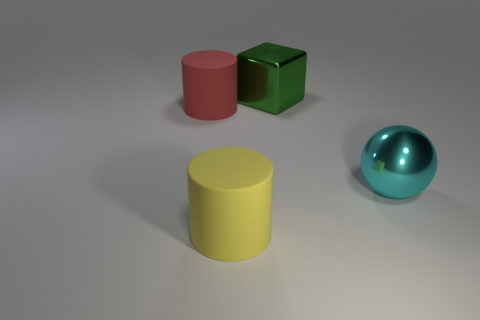What number of other objects are the same shape as the green thing?
Your answer should be very brief. 0. There is a red cylinder that is the same size as the yellow matte cylinder; what is it made of?
Ensure brevity in your answer.  Rubber. Is the shape of the yellow matte thing to the left of the cyan shiny thing the same as the big metallic thing that is behind the big metal ball?
Provide a short and direct response. No. There is a object that is behind the red rubber cylinder; what is it made of?
Ensure brevity in your answer.  Metal. How many objects are objects that are to the right of the big yellow rubber cylinder or large cylinders in front of the red matte cylinder?
Offer a terse response. 3. Are there any metallic spheres of the same size as the green metal block?
Give a very brief answer. Yes. What material is the big thing that is both to the right of the large yellow matte thing and in front of the big green cube?
Your answer should be compact. Metal. What number of rubber objects are brown cylinders or large blocks?
Offer a very short reply. 0. The large red thing that is made of the same material as the big yellow cylinder is what shape?
Give a very brief answer. Cylinder. How many things are both left of the cyan metal object and behind the yellow object?
Offer a terse response. 2. 